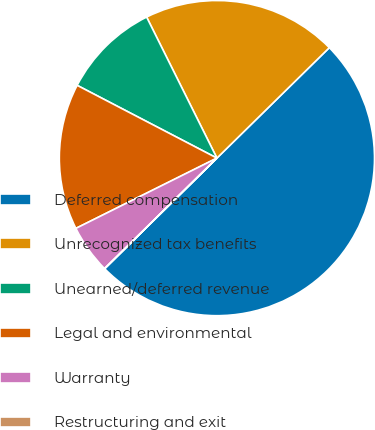<chart> <loc_0><loc_0><loc_500><loc_500><pie_chart><fcel>Deferred compensation<fcel>Unrecognized tax benefits<fcel>Unearned/deferred revenue<fcel>Legal and environmental<fcel>Warranty<fcel>Restructuring and exit<nl><fcel>49.98%<fcel>20.0%<fcel>10.0%<fcel>15.0%<fcel>5.01%<fcel>0.01%<nl></chart> 